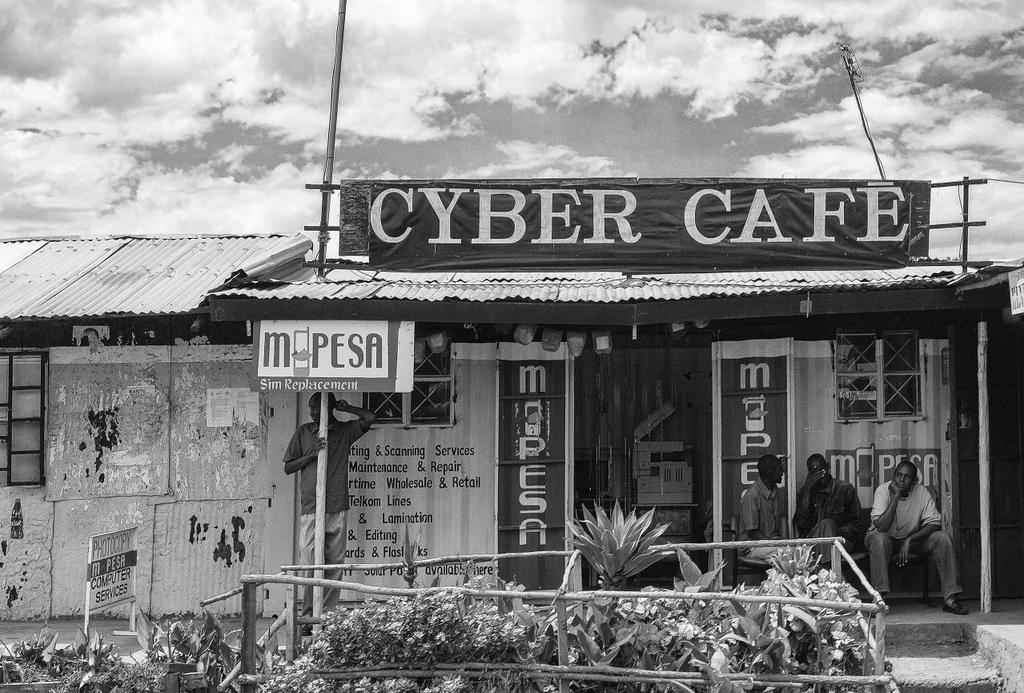<image>
Offer a succinct explanation of the picture presented. A sign above a rustic building that says Cyber Cafe. 